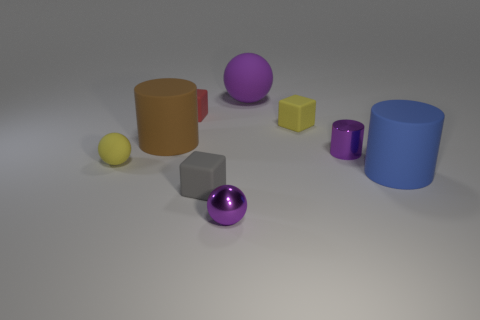Subtract all yellow spheres. How many spheres are left? 2 Subtract 1 cylinders. How many cylinders are left? 2 Add 1 small brown objects. How many objects exist? 10 Subtract all green cylinders. Subtract all yellow spheres. How many cylinders are left? 3 Subtract all blocks. How many objects are left? 6 Subtract 0 gray spheres. How many objects are left? 9 Subtract all yellow spheres. Subtract all small yellow matte balls. How many objects are left? 7 Add 3 blue rubber objects. How many blue rubber objects are left? 4 Add 2 tiny gray objects. How many tiny gray objects exist? 3 